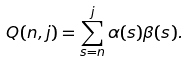<formula> <loc_0><loc_0><loc_500><loc_500>Q ( n , j ) = \sum _ { s = n } ^ { j } \alpha ( s ) \beta ( s ) .</formula> 